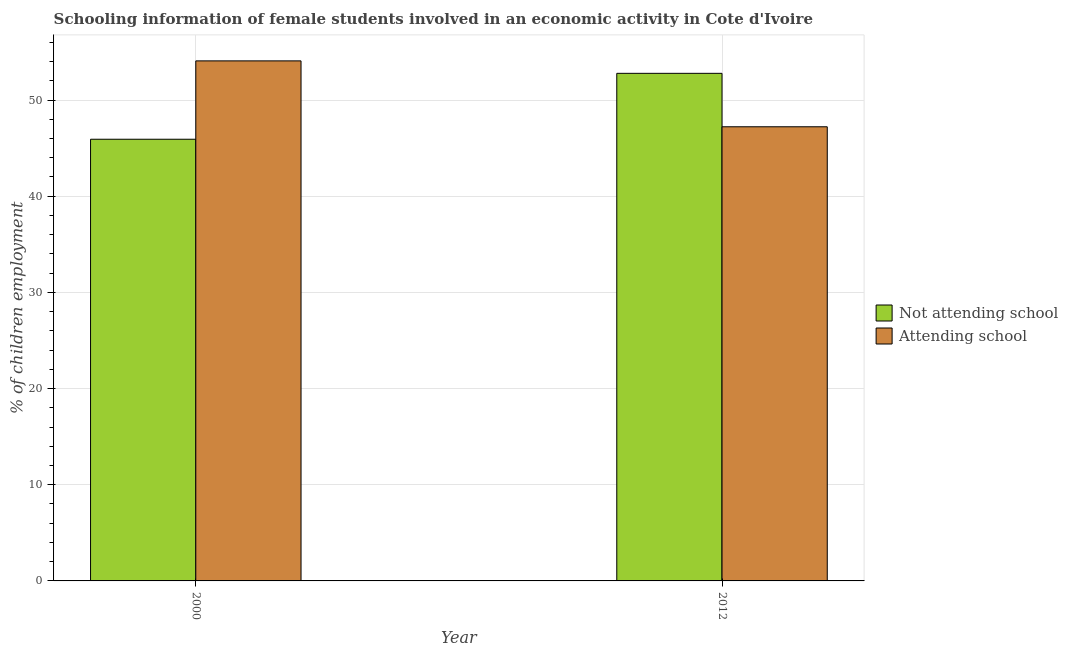How many different coloured bars are there?
Provide a succinct answer. 2. Are the number of bars per tick equal to the number of legend labels?
Provide a succinct answer. Yes. Are the number of bars on each tick of the X-axis equal?
Your answer should be compact. Yes. How many bars are there on the 1st tick from the left?
Make the answer very short. 2. How many bars are there on the 2nd tick from the right?
Offer a terse response. 2. What is the label of the 1st group of bars from the left?
Your response must be concise. 2000. What is the percentage of employed females who are not attending school in 2000?
Make the answer very short. 45.93. Across all years, what is the maximum percentage of employed females who are attending school?
Make the answer very short. 54.07. Across all years, what is the minimum percentage of employed females who are not attending school?
Keep it short and to the point. 45.93. What is the total percentage of employed females who are attending school in the graph?
Provide a short and direct response. 101.3. What is the difference between the percentage of employed females who are not attending school in 2000 and that in 2012?
Offer a very short reply. -6.85. What is the difference between the percentage of employed females who are not attending school in 2012 and the percentage of employed females who are attending school in 2000?
Give a very brief answer. 6.85. What is the average percentage of employed females who are not attending school per year?
Provide a short and direct response. 49.35. In the year 2012, what is the difference between the percentage of employed females who are attending school and percentage of employed females who are not attending school?
Offer a terse response. 0. What is the ratio of the percentage of employed females who are not attending school in 2000 to that in 2012?
Make the answer very short. 0.87. What does the 2nd bar from the left in 2000 represents?
Ensure brevity in your answer.  Attending school. What does the 1st bar from the right in 2000 represents?
Offer a terse response. Attending school. How many bars are there?
Offer a terse response. 4. How many years are there in the graph?
Your answer should be very brief. 2. Are the values on the major ticks of Y-axis written in scientific E-notation?
Your answer should be very brief. No. Does the graph contain grids?
Your response must be concise. Yes. How many legend labels are there?
Your answer should be very brief. 2. What is the title of the graph?
Offer a terse response. Schooling information of female students involved in an economic activity in Cote d'Ivoire. Does "From World Bank" appear as one of the legend labels in the graph?
Keep it short and to the point. No. What is the label or title of the Y-axis?
Keep it short and to the point. % of children employment. What is the % of children employment of Not attending school in 2000?
Your response must be concise. 45.93. What is the % of children employment in Attending school in 2000?
Your answer should be compact. 54.07. What is the % of children employment of Not attending school in 2012?
Keep it short and to the point. 52.78. What is the % of children employment in Attending school in 2012?
Offer a terse response. 47.22. Across all years, what is the maximum % of children employment in Not attending school?
Provide a succinct answer. 52.78. Across all years, what is the maximum % of children employment of Attending school?
Ensure brevity in your answer.  54.07. Across all years, what is the minimum % of children employment of Not attending school?
Keep it short and to the point. 45.93. Across all years, what is the minimum % of children employment in Attending school?
Offer a terse response. 47.22. What is the total % of children employment in Not attending school in the graph?
Your answer should be very brief. 98.7. What is the total % of children employment in Attending school in the graph?
Your answer should be compact. 101.3. What is the difference between the % of children employment of Not attending school in 2000 and that in 2012?
Offer a terse response. -6.85. What is the difference between the % of children employment of Attending school in 2000 and that in 2012?
Offer a terse response. 6.85. What is the difference between the % of children employment of Not attending school in 2000 and the % of children employment of Attending school in 2012?
Your answer should be very brief. -1.3. What is the average % of children employment of Not attending school per year?
Give a very brief answer. 49.35. What is the average % of children employment of Attending school per year?
Offer a terse response. 50.65. In the year 2000, what is the difference between the % of children employment of Not attending school and % of children employment of Attending school?
Provide a short and direct response. -8.15. In the year 2012, what is the difference between the % of children employment of Not attending school and % of children employment of Attending school?
Ensure brevity in your answer.  5.56. What is the ratio of the % of children employment in Not attending school in 2000 to that in 2012?
Your answer should be very brief. 0.87. What is the ratio of the % of children employment in Attending school in 2000 to that in 2012?
Offer a terse response. 1.15. What is the difference between the highest and the second highest % of children employment in Not attending school?
Your answer should be very brief. 6.85. What is the difference between the highest and the second highest % of children employment of Attending school?
Provide a short and direct response. 6.85. What is the difference between the highest and the lowest % of children employment of Not attending school?
Provide a succinct answer. 6.85. What is the difference between the highest and the lowest % of children employment in Attending school?
Give a very brief answer. 6.85. 